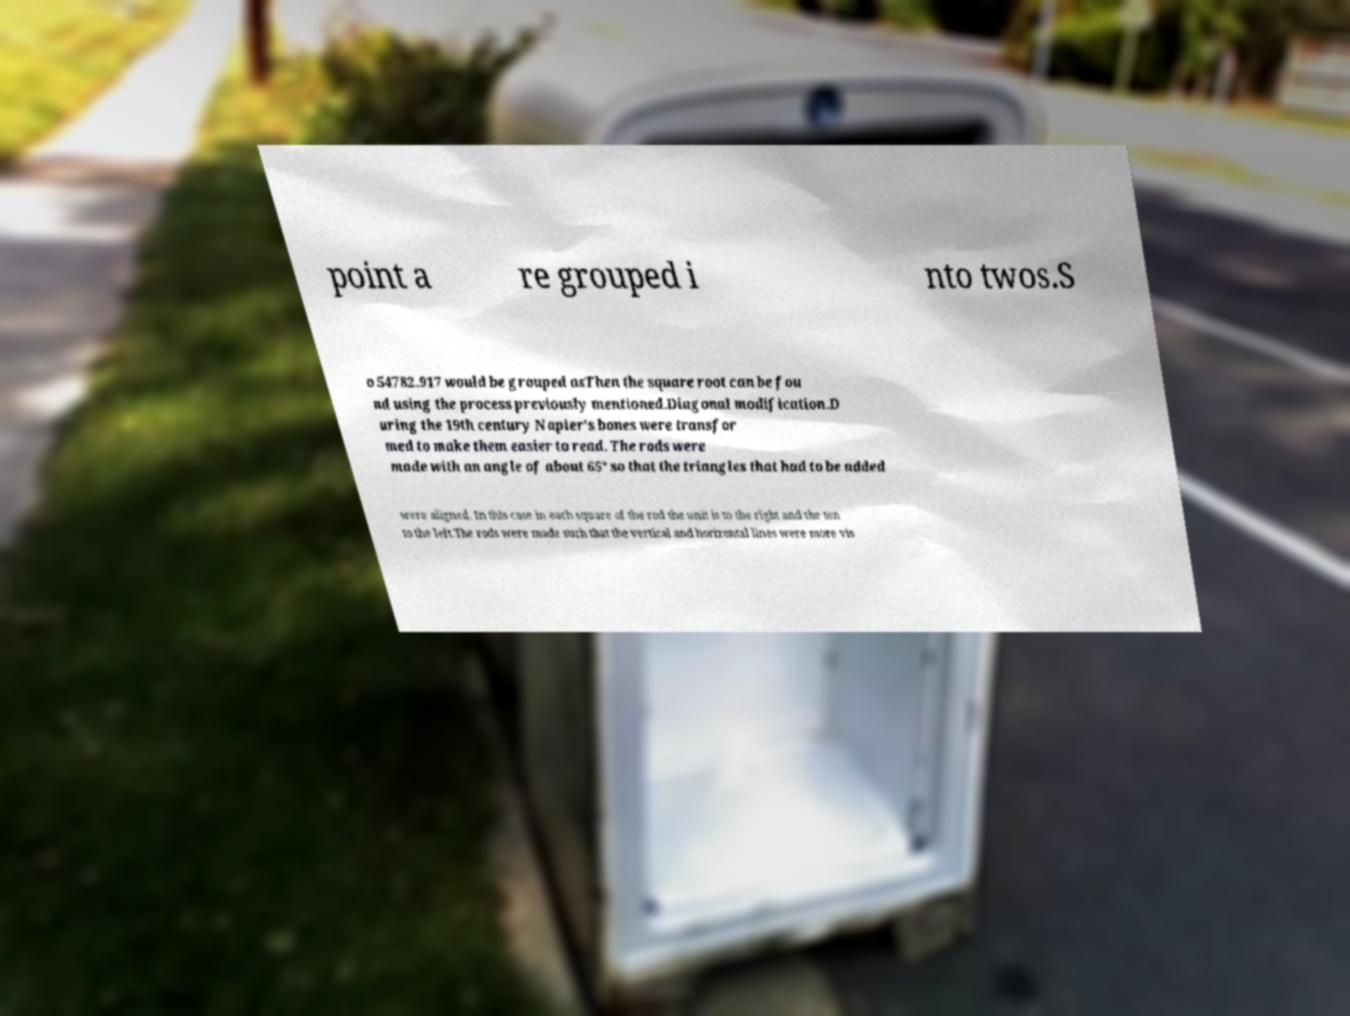What messages or text are displayed in this image? I need them in a readable, typed format. point a re grouped i nto twos.S o 54782.917 would be grouped asThen the square root can be fou nd using the process previously mentioned.Diagonal modification.D uring the 19th century Napier's bones were transfor med to make them easier to read. The rods were made with an angle of about 65° so that the triangles that had to be added were aligned. In this case in each square of the rod the unit is to the right and the ten to the left.The rods were made such that the vertical and horizontal lines were more vis 